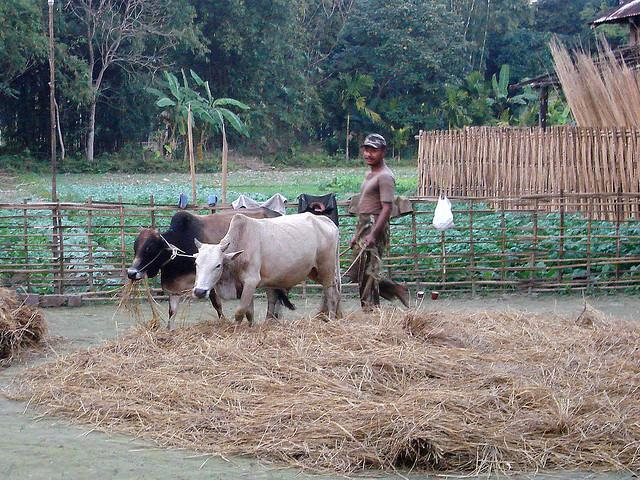What keeps the cattle from eating the garden here? fence 